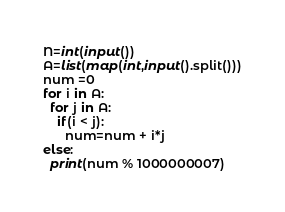<code> <loc_0><loc_0><loc_500><loc_500><_Python_>N=int(input())
A=list(map(int,input().split()))
num =0
for i in A:
  for j in A:
    if(i < j):
      num=num + i*j
else:
  print(num % 1000000007)

</code> 